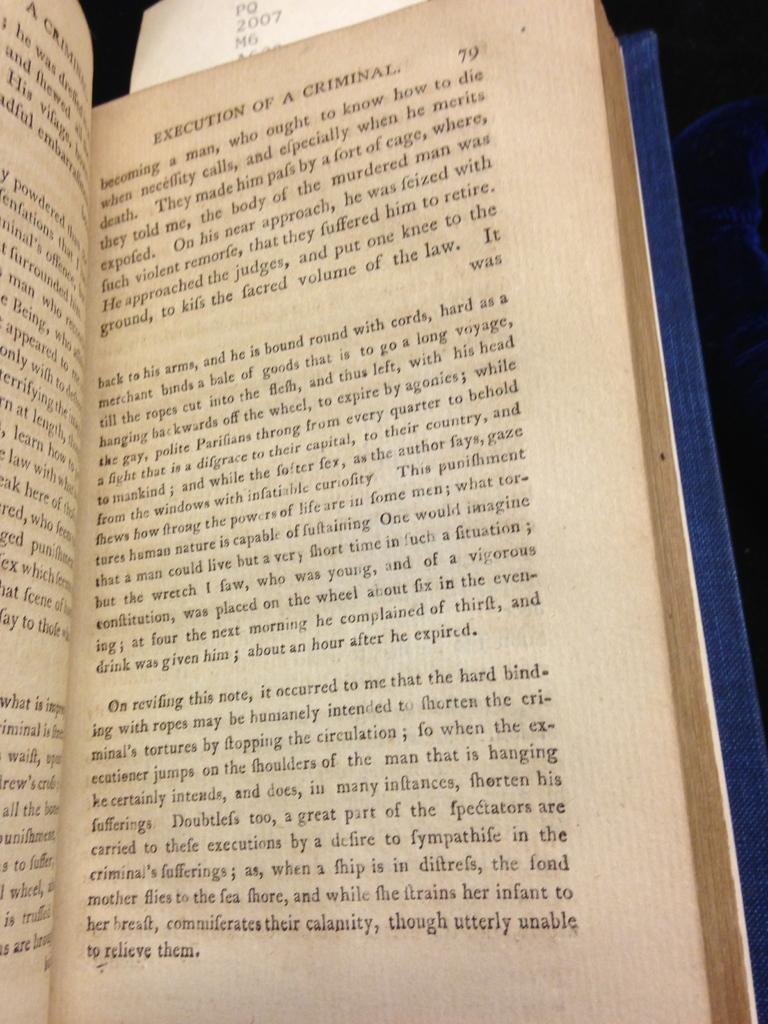What is the main object in the image? There is an opened book in the image. Can you describe the state of the book? The book is opened in the image. What type of muscle can be seen flexing in the image? There is no muscle present in the image; it only features an opened book. 